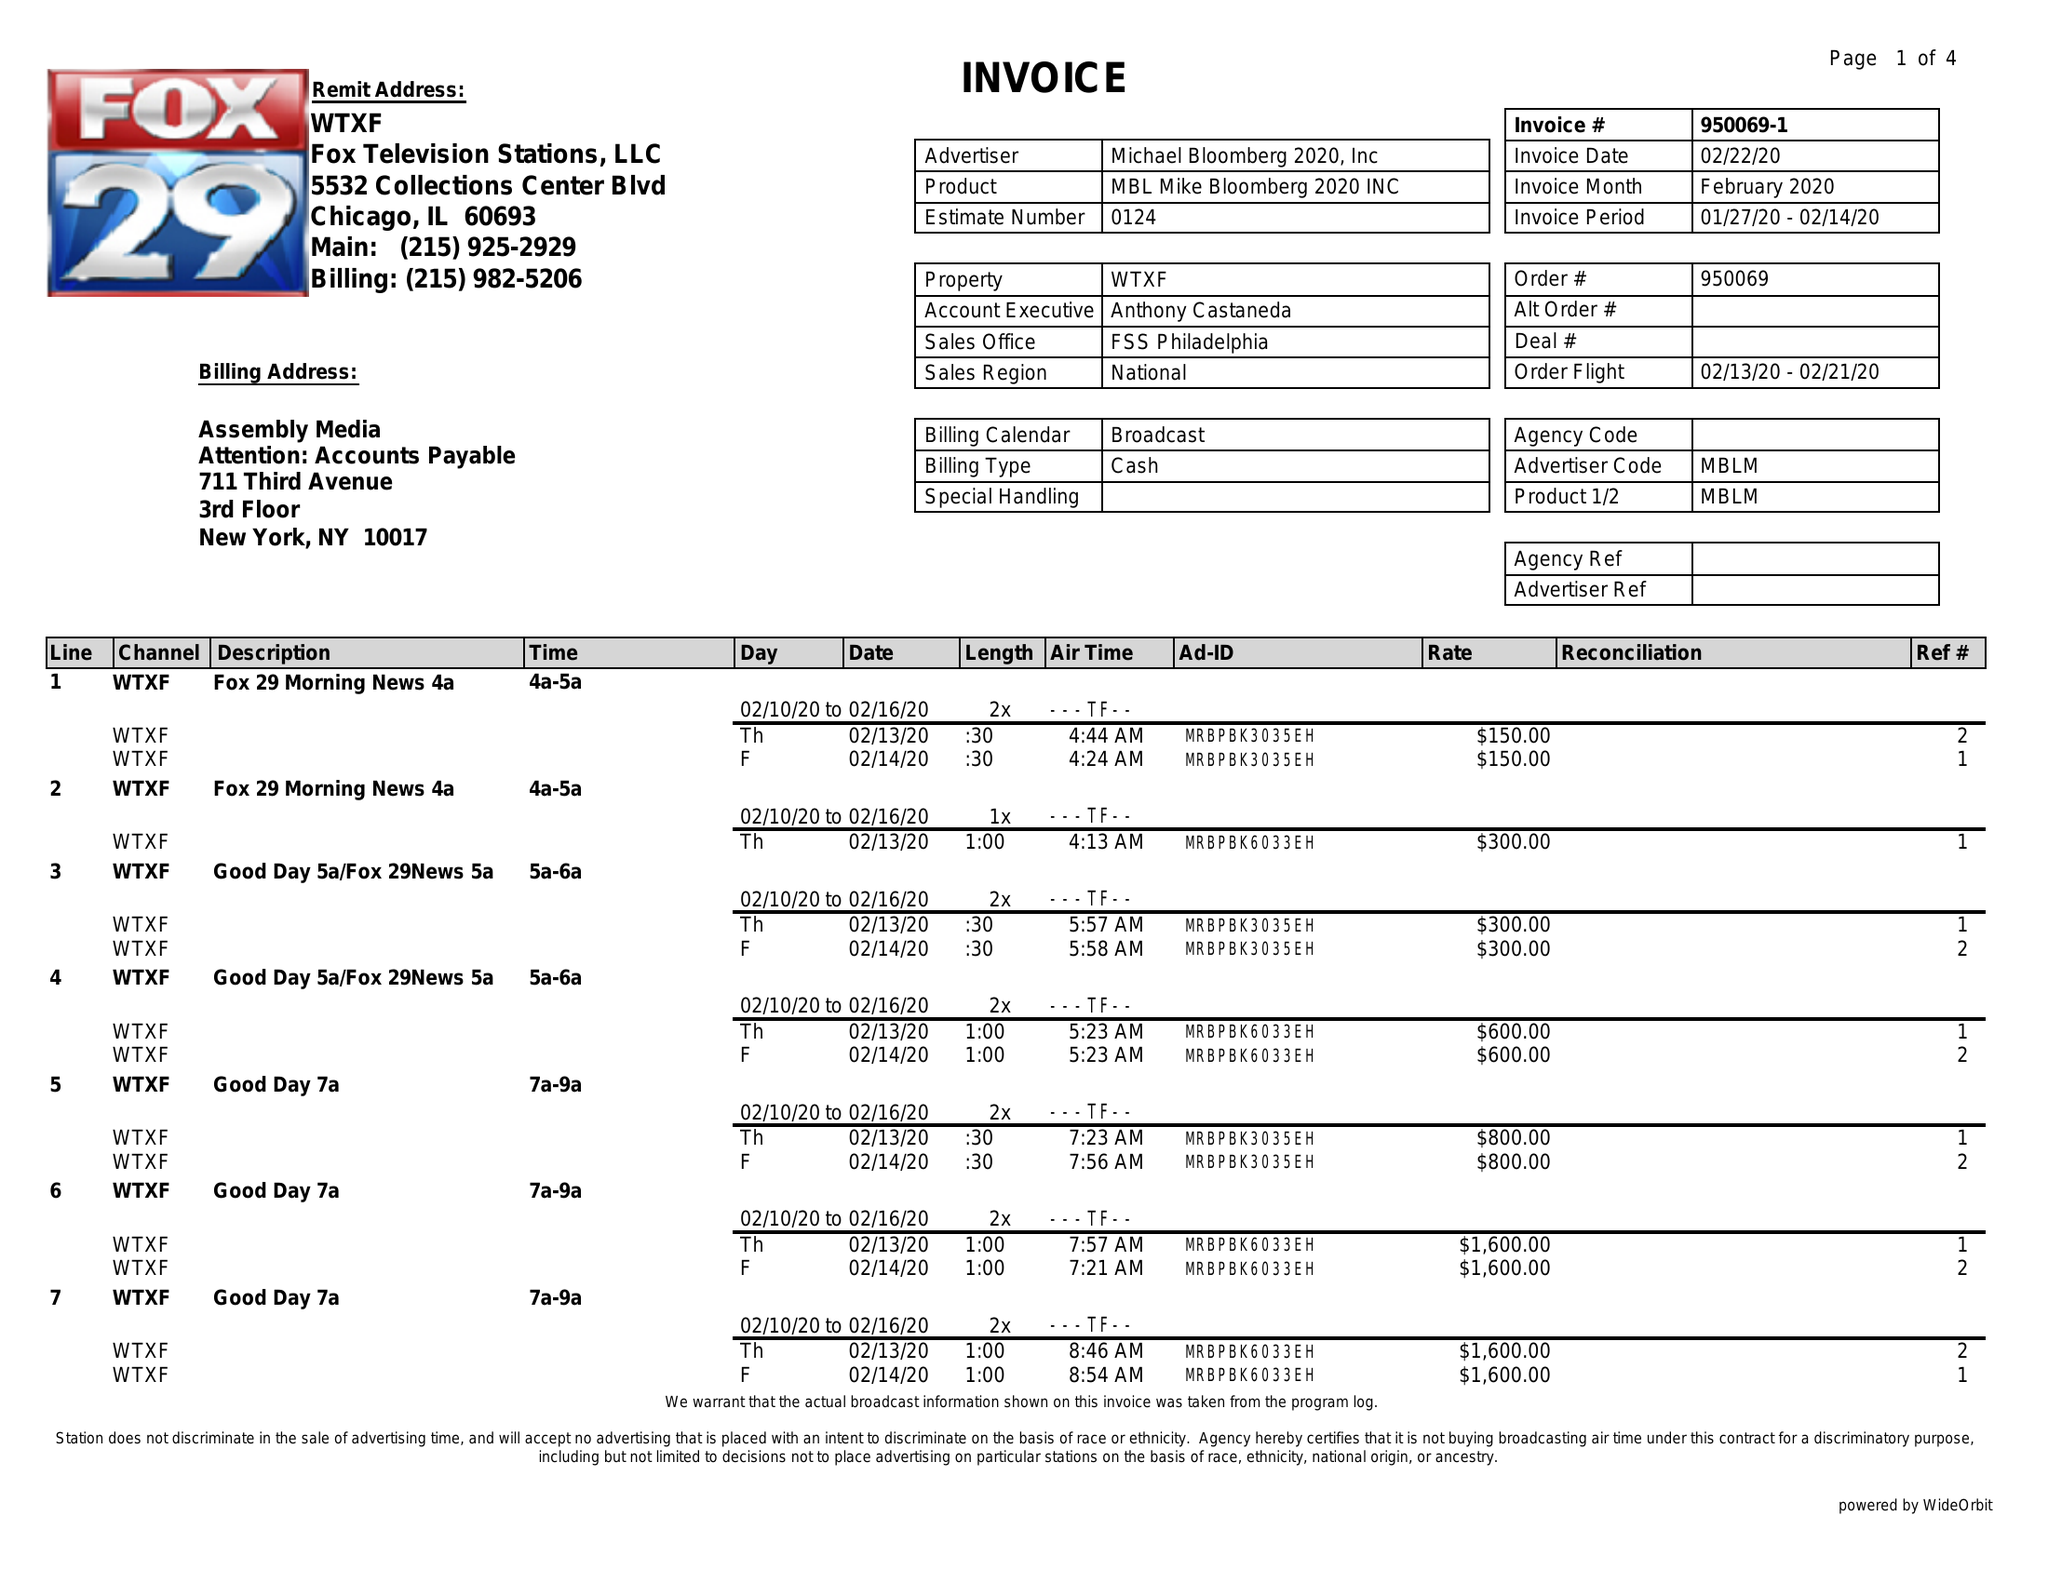What is the value for the flight_from?
Answer the question using a single word or phrase. 02/13/20 